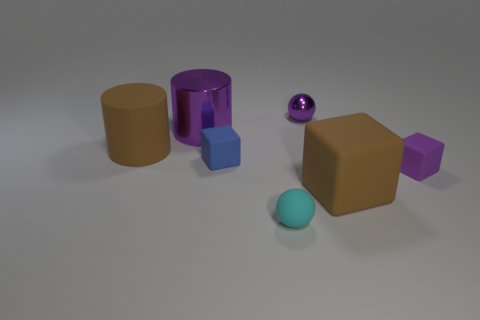Add 2 brown things. How many objects exist? 9 Subtract all spheres. How many objects are left? 5 Add 1 big blue shiny cubes. How many big blue shiny cubes exist? 1 Subtract 1 blue cubes. How many objects are left? 6 Subtract all big gray metal objects. Subtract all blue objects. How many objects are left? 6 Add 3 large cubes. How many large cubes are left? 4 